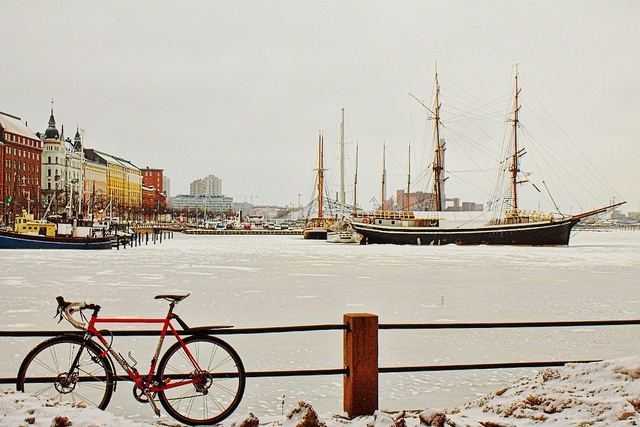Describe the objects in this image and their specific colors. I can see bicycle in lightgray, black, and darkgray tones, boat in lightgray, black, tan, and darkgray tones, boat in lightgray, black, navy, maroon, and gold tones, boat in lightgray, black, brown, and tan tones, and boat in lightgray, darkgray, and tan tones in this image. 